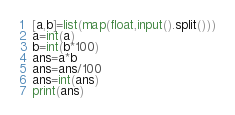Convert code to text. <code><loc_0><loc_0><loc_500><loc_500><_Python_>[a,b]=list(map(float,input().split()))
a=int(a)
b=int(b*100)
ans=a*b
ans=ans/100
ans=int(ans)
print(ans)</code> 